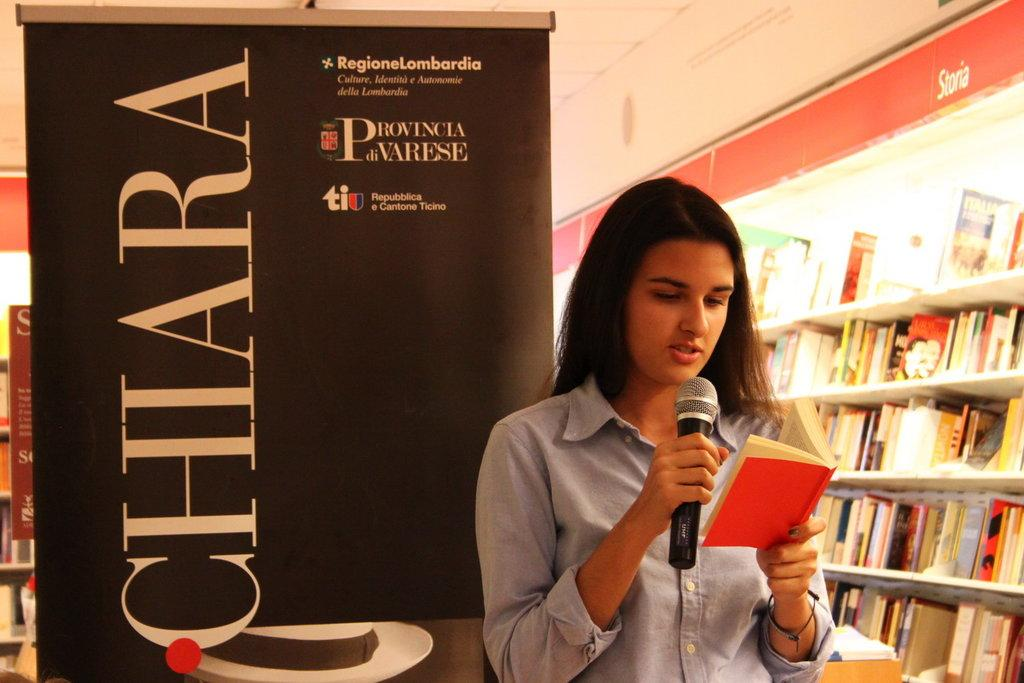What is the person in the image doing? The person is holding a microphone and a book. What is the person wearing in the image? The person is wearing a blue shirt. Are there any other items visible in the image besides the person? Yes, there are books visible in the background of the image, on shelves. Can you see any women holding a rifle in the image? There are no women or rifles present in the image. 